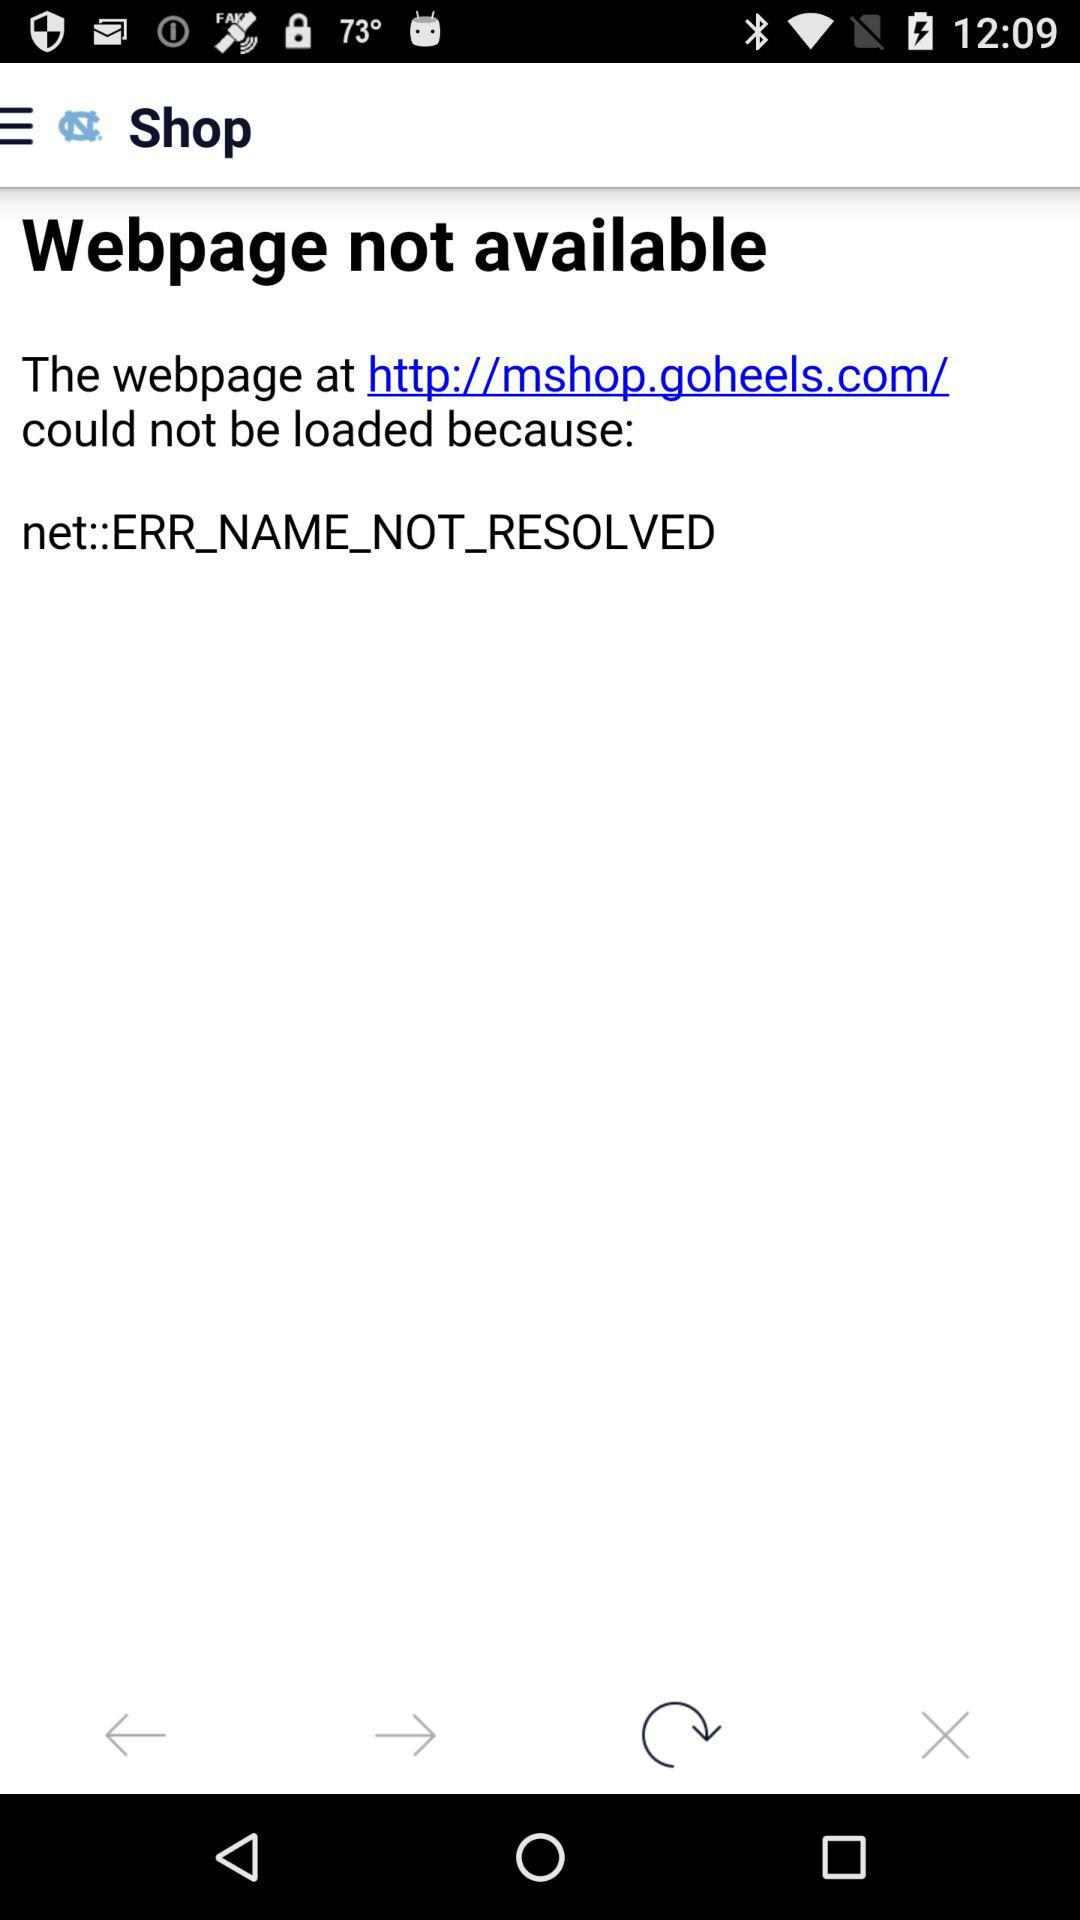Which tab is currently selected?
When the provided information is insufficient, respond with <no answer>. <no answer> 